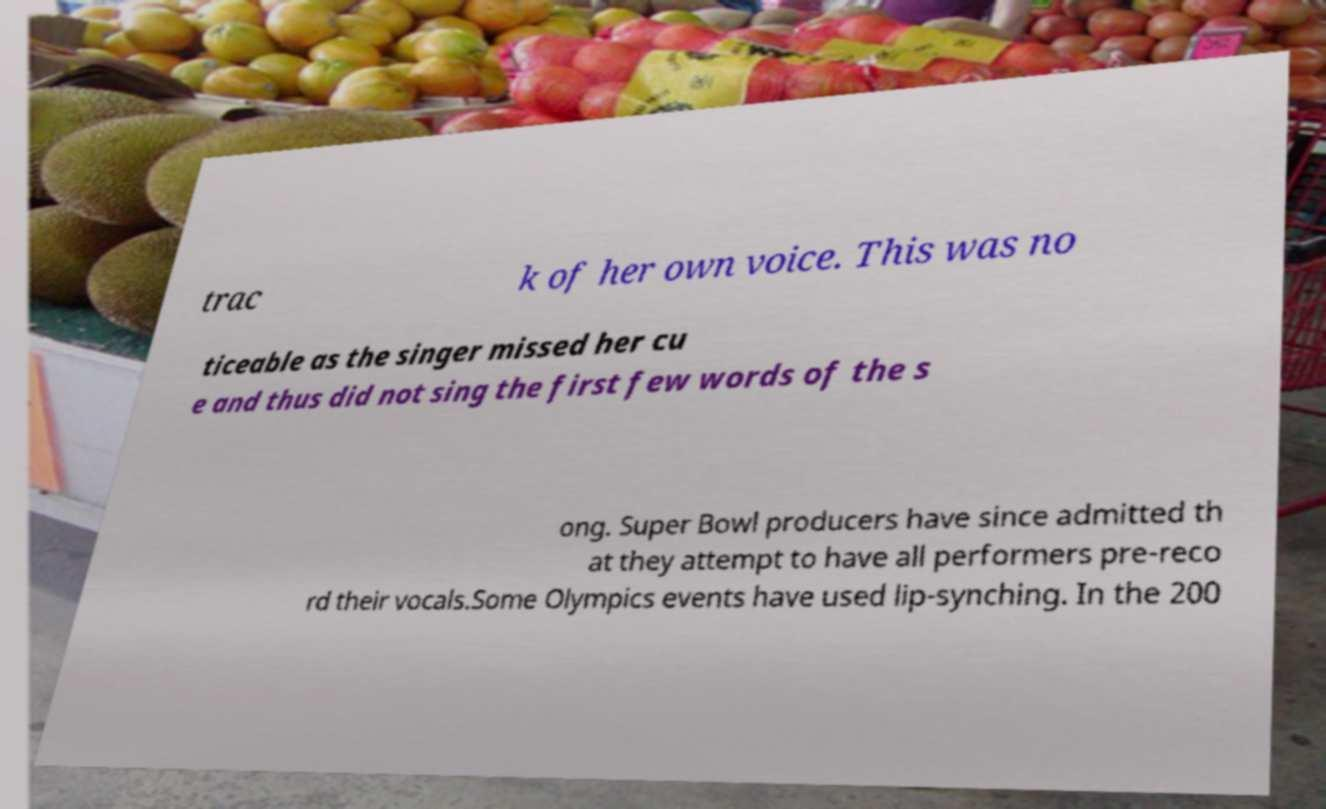There's text embedded in this image that I need extracted. Can you transcribe it verbatim? trac k of her own voice. This was no ticeable as the singer missed her cu e and thus did not sing the first few words of the s ong. Super Bowl producers have since admitted th at they attempt to have all performers pre-reco rd their vocals.Some Olympics events have used lip-synching. In the 200 